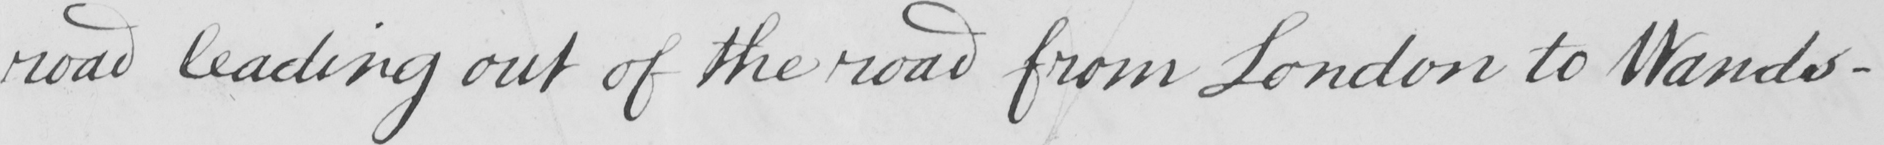Please transcribe the handwritten text in this image. road leading out of the road from London to Wands- 